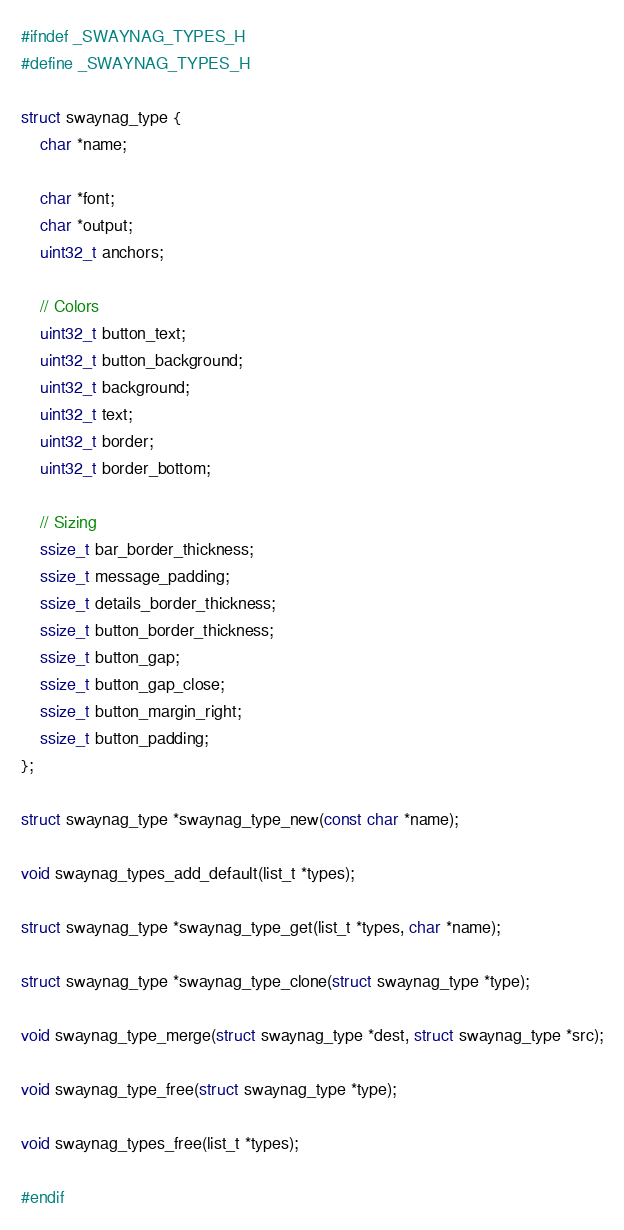<code> <loc_0><loc_0><loc_500><loc_500><_C_>#ifndef _SWAYNAG_TYPES_H
#define _SWAYNAG_TYPES_H

struct swaynag_type {
	char *name;

	char *font;
	char *output;
	uint32_t anchors;

	// Colors
	uint32_t button_text;
	uint32_t button_background;
	uint32_t background;
	uint32_t text;
	uint32_t border;
	uint32_t border_bottom;

	// Sizing
	ssize_t bar_border_thickness;
	ssize_t message_padding;
	ssize_t details_border_thickness;
	ssize_t button_border_thickness;
	ssize_t button_gap;
	ssize_t button_gap_close;
	ssize_t button_margin_right;
	ssize_t button_padding;
};

struct swaynag_type *swaynag_type_new(const char *name);

void swaynag_types_add_default(list_t *types);

struct swaynag_type *swaynag_type_get(list_t *types, char *name);

struct swaynag_type *swaynag_type_clone(struct swaynag_type *type);

void swaynag_type_merge(struct swaynag_type *dest, struct swaynag_type *src);

void swaynag_type_free(struct swaynag_type *type);

void swaynag_types_free(list_t *types);

#endif
</code> 